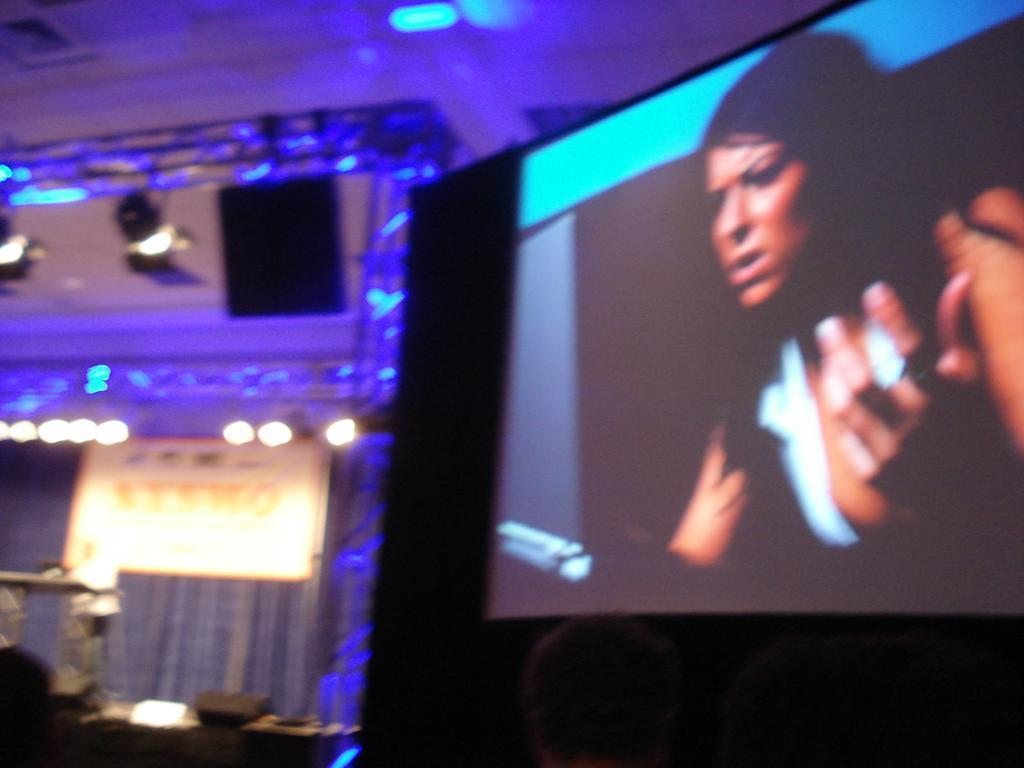What is the main subject on the screen in the image? There is a person on the screen in the image. What can be seen in the background of the image? There are lights, frames, other objects, and a cloth in the background. Can you describe the roof at the top of the image? There is a roof at the top of the image. What type of soap is being used by the mother in the image? There is no mother or soap present in the image; it features a person on the screen with a background containing lights, frames, other objects, and a cloth. 